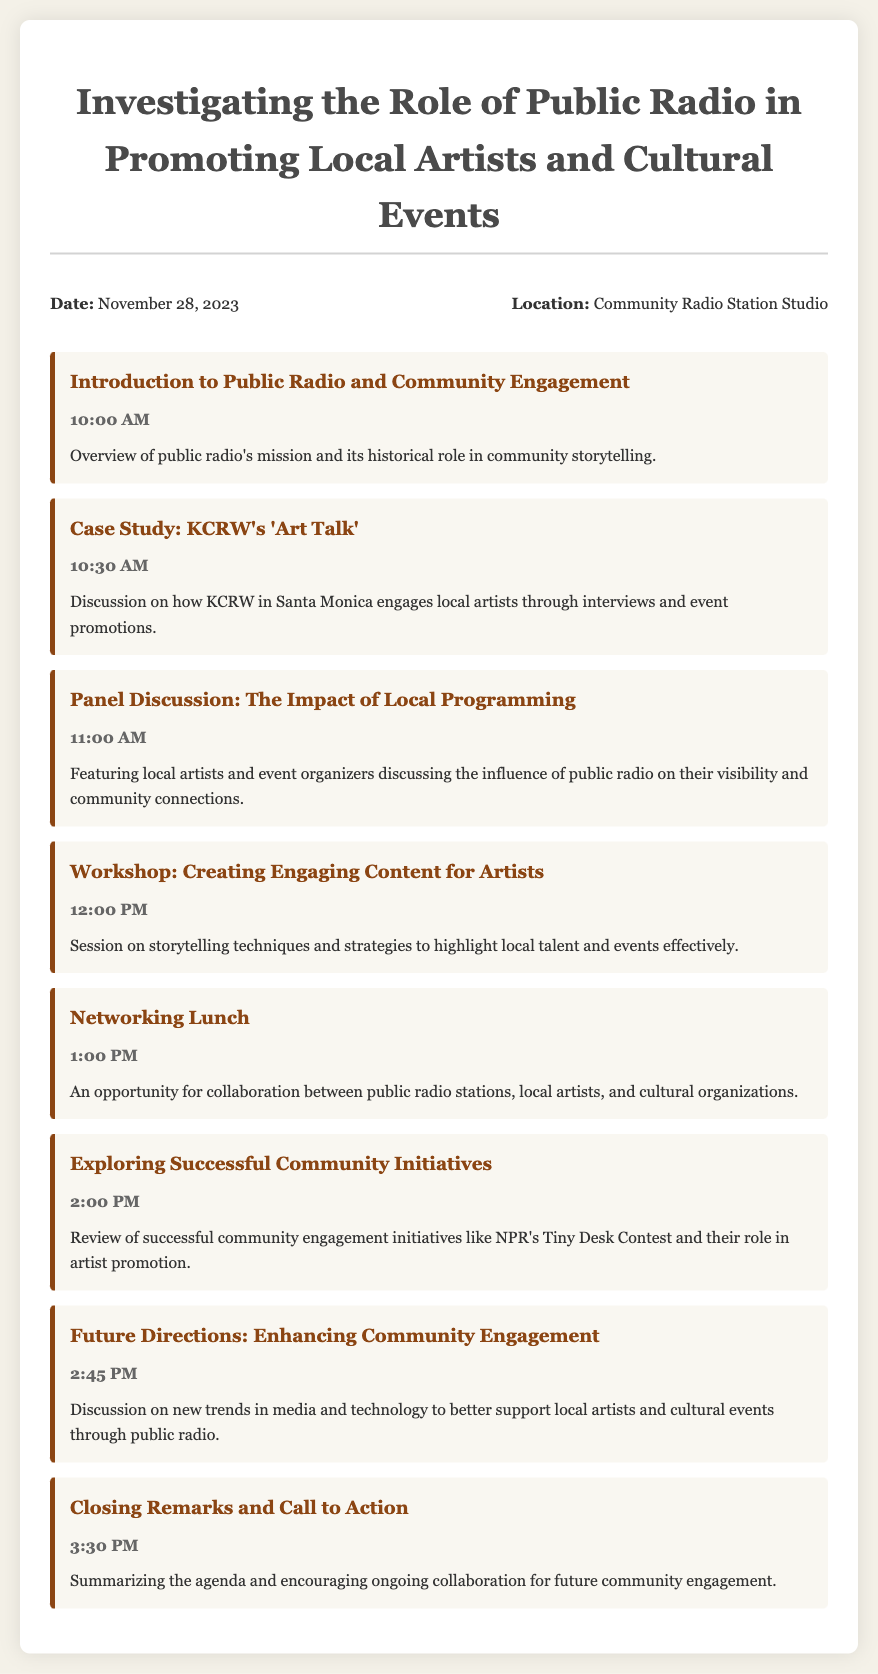What is the date of the event? The date of the event is explicitly mentioned in the document as November 28, 2023.
Answer: November 28, 2023 What time does the workshop start? The document specifies that the workshop titled "Creating Engaging Content for Artists" takes place at 12:00 PM.
Answer: 12:00 PM Who is featured in the panel discussion? The panel discussion includes local artists and event organizers discussing their experiences with public radio.
Answer: Local artists and event organizers What is the location of the agenda event? The document states that the location of the event is the Community Radio Station Studio.
Answer: Community Radio Station Studio What is the purpose of the networking lunch? The document describes the networking lunch as an opportunity for collaboration between public radio stations, local artists, and cultural organizations.
Answer: Collaboration opportunity How long is the closing remarks session? By looking at the agenda timings, the closing remarks session starts at 3:30 PM and does not overlap with another session, indicating a brief conclusion.
Answer: Brief Which organization is mentioned in the context of successful community initiatives? The document mentions NPR's Tiny Desk Contest as a successful community engagement initiative.
Answer: NPR What is the focus of the workshop? The workshop aims to teach storytelling techniques and strategies to effectively highlight local talent and events.
Answer: Storytelling techniques What time does the event start? The event starts at 10:00 AM as noted in the agenda for the introduction session.
Answer: 10:00 AM 